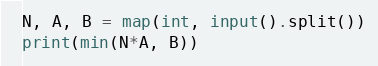<code> <loc_0><loc_0><loc_500><loc_500><_Python_>N, A, B = map(int, input().split())
print(min(N*A, B))</code> 